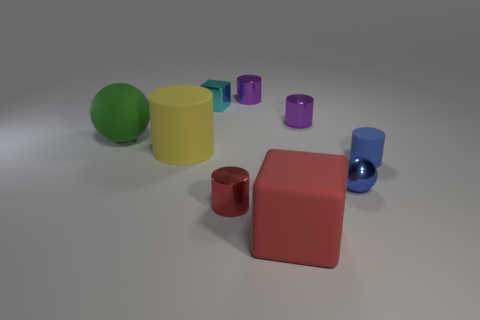Subtract 2 cylinders. How many cylinders are left? 3 Subtract all green cylinders. Subtract all cyan blocks. How many cylinders are left? 5 Subtract all spheres. How many objects are left? 7 Add 4 small cyan blocks. How many small cyan blocks are left? 5 Add 4 big cylinders. How many big cylinders exist? 5 Subtract 0 cyan balls. How many objects are left? 9 Subtract all large blocks. Subtract all blue matte things. How many objects are left? 7 